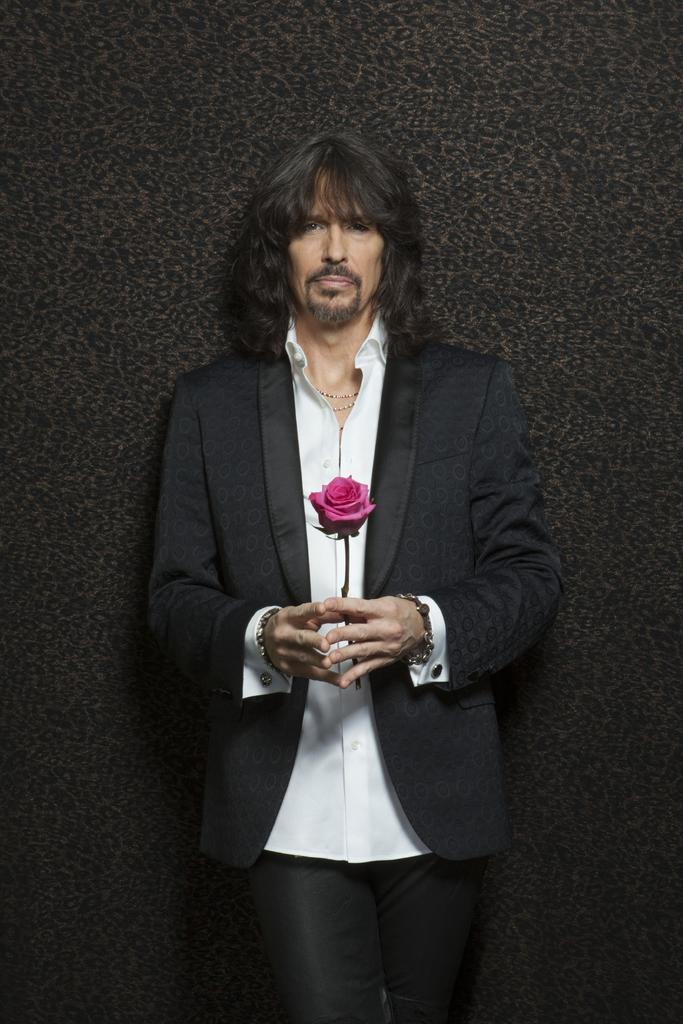Who is the main subject in the image? There is a man in the image. Where is the man positioned in the image? The man is standing in the center of the image. What is the man holding in his hands? The man is holding a rose in his hands. What type of cactus is growing on the man's finger in the image? There is no cactus growing on the man's finger in the image; he is holding a rose. What is the current temperature in the image? The provided facts do not give any information about the temperature, so it cannot be determined from the image. 